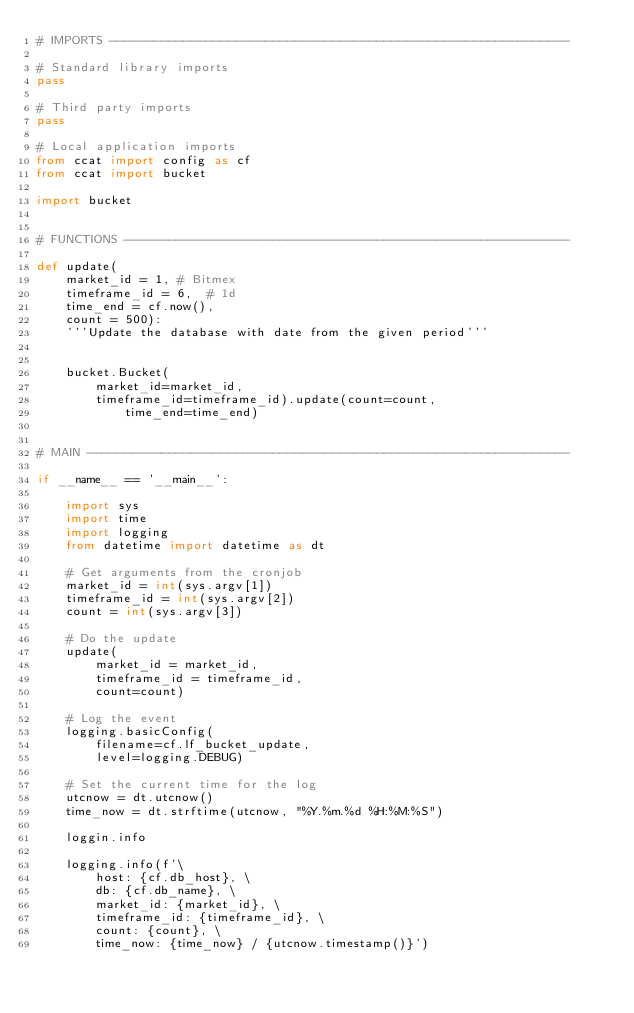<code> <loc_0><loc_0><loc_500><loc_500><_Python_># IMPORTS --------------------------------------------------------------

# Standard library imports
pass

# Third party imports
pass

# Local application imports
from ccat import config as cf
from ccat import bucket

import bucket


# FUNCTIONS ------------------------------------------------------------

def update(
    market_id = 1, # Bitmex
    timeframe_id = 6,  # 1d
    time_end = cf.now(),
    count = 500):
    '''Update the database with date from the given period'''


    bucket.Bucket(
        market_id=market_id,
        timeframe_id=timeframe_id).update(count=count,
            time_end=time_end)


# MAIN -----------------------------------------------------------------

if __name__ == '__main__':

    import sys
    import time
    import logging
    from datetime import datetime as dt

    # Get arguments from the cronjob
    market_id = int(sys.argv[1])
    timeframe_id = int(sys.argv[2])
    count = int(sys.argv[3])

    # Do the update
    update(
        market_id = market_id,
        timeframe_id = timeframe_id,
        count=count)

    # Log the event
    logging.basicConfig(
        filename=cf.lf_bucket_update,
        level=logging.DEBUG)

    # Set the current time for the log
    utcnow = dt.utcnow()
    time_now = dt.strftime(utcnow, "%Y.%m.%d %H:%M:%S")

    loggin.info

    logging.info(f'\
        host: {cf.db_host}, \
        db: {cf.db_name}, \
        market_id: {market_id}, \
        timeframe_id: {timeframe_id}, \
        count: {count}, \
        time_now: {time_now} / {utcnow.timestamp()}')
</code> 